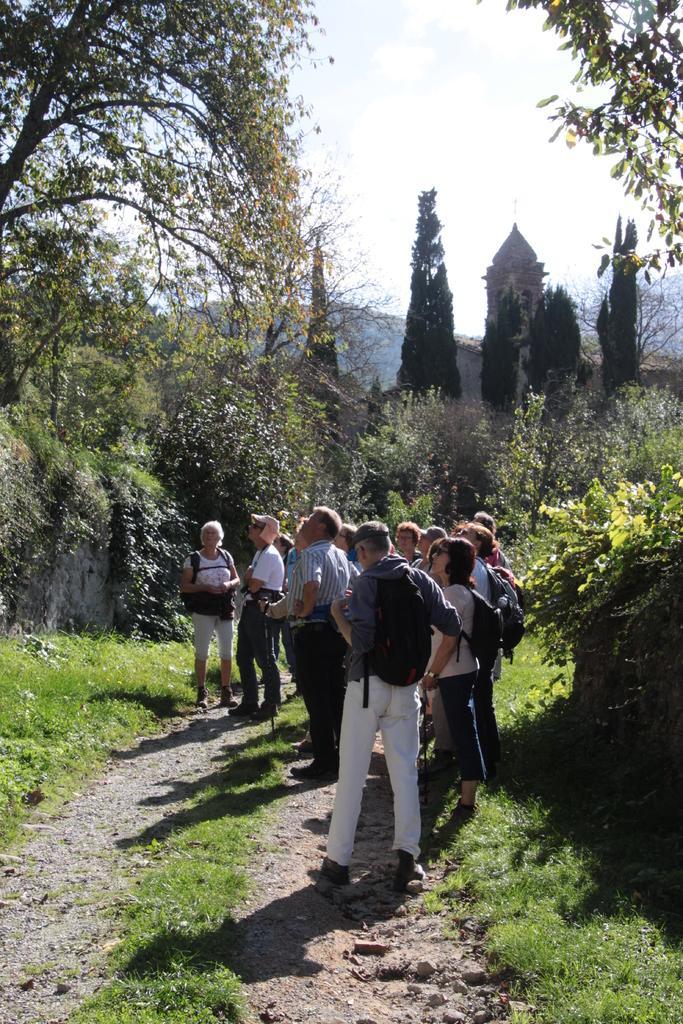Could you give a brief overview of what you see in this image? In this image I can see the group of people standing on the ground. These people are wearing the different color dresses and the bags. To the side of these people I can see many trees. In the background there are mountains and the white sky. 